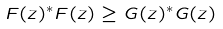Convert formula to latex. <formula><loc_0><loc_0><loc_500><loc_500>F ( z ) ^ { * } F ( z ) \geq G ( z ) ^ { * } G ( z )</formula> 